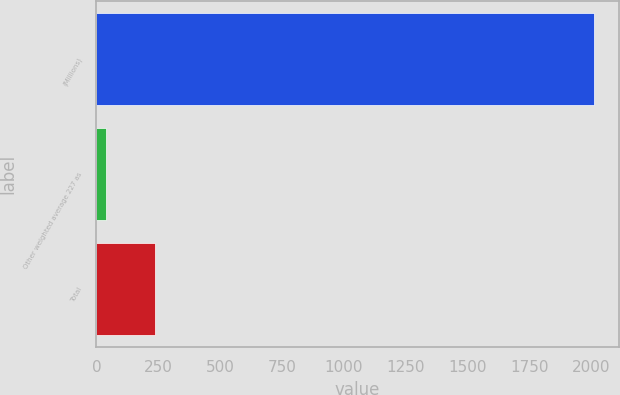Convert chart. <chart><loc_0><loc_0><loc_500><loc_500><bar_chart><fcel>(Millions)<fcel>Other weighted average 227 as<fcel>Total<nl><fcel>2012<fcel>39<fcel>236.3<nl></chart> 